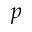Convert formula to latex. <formula><loc_0><loc_0><loc_500><loc_500>p</formula> 